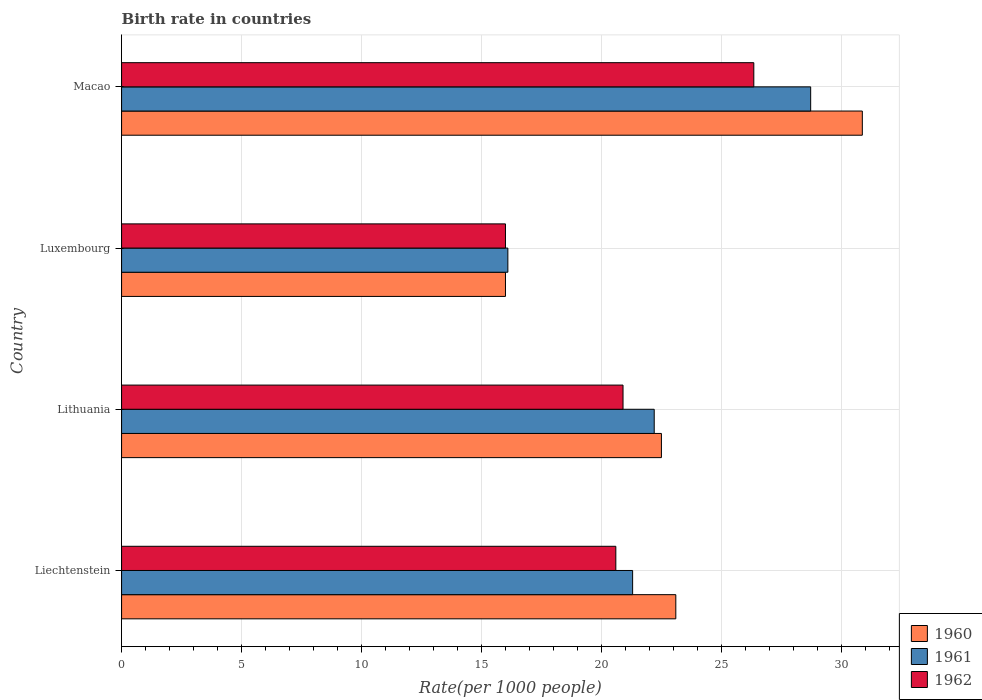Are the number of bars on each tick of the Y-axis equal?
Provide a succinct answer. Yes. How many bars are there on the 3rd tick from the bottom?
Your answer should be very brief. 3. What is the label of the 2nd group of bars from the top?
Make the answer very short. Luxembourg. What is the birth rate in 1960 in Liechtenstein?
Offer a very short reply. 23.1. Across all countries, what is the maximum birth rate in 1962?
Your response must be concise. 26.35. Across all countries, what is the minimum birth rate in 1962?
Ensure brevity in your answer.  16. In which country was the birth rate in 1962 maximum?
Give a very brief answer. Macao. In which country was the birth rate in 1962 minimum?
Keep it short and to the point. Luxembourg. What is the total birth rate in 1961 in the graph?
Your response must be concise. 88.32. What is the difference between the birth rate in 1961 in Liechtenstein and that in Luxembourg?
Provide a succinct answer. 5.2. What is the difference between the birth rate in 1961 in Macao and the birth rate in 1962 in Liechtenstein?
Offer a very short reply. 8.12. What is the average birth rate in 1962 per country?
Offer a very short reply. 20.96. What is the difference between the birth rate in 1961 and birth rate in 1960 in Liechtenstein?
Provide a short and direct response. -1.8. In how many countries, is the birth rate in 1961 greater than 30 ?
Keep it short and to the point. 0. What is the ratio of the birth rate in 1961 in Lithuania to that in Macao?
Make the answer very short. 0.77. Is the birth rate in 1962 in Liechtenstein less than that in Macao?
Give a very brief answer. Yes. Is the difference between the birth rate in 1961 in Liechtenstein and Luxembourg greater than the difference between the birth rate in 1960 in Liechtenstein and Luxembourg?
Your answer should be very brief. No. What is the difference between the highest and the second highest birth rate in 1962?
Your response must be concise. 5.45. What is the difference between the highest and the lowest birth rate in 1961?
Keep it short and to the point. 12.62. Is the sum of the birth rate in 1961 in Luxembourg and Macao greater than the maximum birth rate in 1960 across all countries?
Give a very brief answer. Yes. What does the 2nd bar from the top in Macao represents?
Offer a very short reply. 1961. What does the 1st bar from the bottom in Luxembourg represents?
Your answer should be compact. 1960. Is it the case that in every country, the sum of the birth rate in 1961 and birth rate in 1960 is greater than the birth rate in 1962?
Give a very brief answer. Yes. How many countries are there in the graph?
Your answer should be very brief. 4. Are the values on the major ticks of X-axis written in scientific E-notation?
Offer a terse response. No. How many legend labels are there?
Your response must be concise. 3. How are the legend labels stacked?
Offer a terse response. Vertical. What is the title of the graph?
Offer a very short reply. Birth rate in countries. What is the label or title of the X-axis?
Your answer should be compact. Rate(per 1000 people). What is the label or title of the Y-axis?
Offer a very short reply. Country. What is the Rate(per 1000 people) of 1960 in Liechtenstein?
Make the answer very short. 23.1. What is the Rate(per 1000 people) in 1961 in Liechtenstein?
Ensure brevity in your answer.  21.3. What is the Rate(per 1000 people) in 1962 in Liechtenstein?
Provide a short and direct response. 20.6. What is the Rate(per 1000 people) in 1962 in Lithuania?
Provide a succinct answer. 20.9. What is the Rate(per 1000 people) of 1960 in Luxembourg?
Provide a succinct answer. 16. What is the Rate(per 1000 people) in 1962 in Luxembourg?
Ensure brevity in your answer.  16. What is the Rate(per 1000 people) of 1960 in Macao?
Your answer should be compact. 30.87. What is the Rate(per 1000 people) in 1961 in Macao?
Offer a very short reply. 28.72. What is the Rate(per 1000 people) in 1962 in Macao?
Provide a succinct answer. 26.35. Across all countries, what is the maximum Rate(per 1000 people) in 1960?
Give a very brief answer. 30.87. Across all countries, what is the maximum Rate(per 1000 people) in 1961?
Keep it short and to the point. 28.72. Across all countries, what is the maximum Rate(per 1000 people) of 1962?
Give a very brief answer. 26.35. Across all countries, what is the minimum Rate(per 1000 people) of 1961?
Provide a succinct answer. 16.1. What is the total Rate(per 1000 people) in 1960 in the graph?
Make the answer very short. 92.47. What is the total Rate(per 1000 people) in 1961 in the graph?
Offer a terse response. 88.32. What is the total Rate(per 1000 people) in 1962 in the graph?
Offer a terse response. 83.85. What is the difference between the Rate(per 1000 people) of 1961 in Liechtenstein and that in Lithuania?
Ensure brevity in your answer.  -0.9. What is the difference between the Rate(per 1000 people) in 1961 in Liechtenstein and that in Luxembourg?
Make the answer very short. 5.2. What is the difference between the Rate(per 1000 people) in 1960 in Liechtenstein and that in Macao?
Your response must be concise. -7.77. What is the difference between the Rate(per 1000 people) of 1961 in Liechtenstein and that in Macao?
Ensure brevity in your answer.  -7.42. What is the difference between the Rate(per 1000 people) in 1962 in Liechtenstein and that in Macao?
Provide a succinct answer. -5.75. What is the difference between the Rate(per 1000 people) in 1960 in Lithuania and that in Luxembourg?
Your answer should be very brief. 6.5. What is the difference between the Rate(per 1000 people) of 1960 in Lithuania and that in Macao?
Your answer should be very brief. -8.37. What is the difference between the Rate(per 1000 people) of 1961 in Lithuania and that in Macao?
Keep it short and to the point. -6.52. What is the difference between the Rate(per 1000 people) of 1962 in Lithuania and that in Macao?
Offer a terse response. -5.45. What is the difference between the Rate(per 1000 people) in 1960 in Luxembourg and that in Macao?
Give a very brief answer. -14.87. What is the difference between the Rate(per 1000 people) in 1961 in Luxembourg and that in Macao?
Make the answer very short. -12.62. What is the difference between the Rate(per 1000 people) in 1962 in Luxembourg and that in Macao?
Your answer should be very brief. -10.35. What is the difference between the Rate(per 1000 people) in 1960 in Liechtenstein and the Rate(per 1000 people) in 1961 in Lithuania?
Provide a short and direct response. 0.9. What is the difference between the Rate(per 1000 people) in 1961 in Liechtenstein and the Rate(per 1000 people) in 1962 in Lithuania?
Your answer should be very brief. 0.4. What is the difference between the Rate(per 1000 people) in 1960 in Liechtenstein and the Rate(per 1000 people) in 1961 in Luxembourg?
Provide a short and direct response. 7. What is the difference between the Rate(per 1000 people) of 1960 in Liechtenstein and the Rate(per 1000 people) of 1962 in Luxembourg?
Your response must be concise. 7.1. What is the difference between the Rate(per 1000 people) of 1960 in Liechtenstein and the Rate(per 1000 people) of 1961 in Macao?
Offer a very short reply. -5.62. What is the difference between the Rate(per 1000 people) in 1960 in Liechtenstein and the Rate(per 1000 people) in 1962 in Macao?
Provide a short and direct response. -3.25. What is the difference between the Rate(per 1000 people) in 1961 in Liechtenstein and the Rate(per 1000 people) in 1962 in Macao?
Make the answer very short. -5.05. What is the difference between the Rate(per 1000 people) in 1961 in Lithuania and the Rate(per 1000 people) in 1962 in Luxembourg?
Offer a terse response. 6.2. What is the difference between the Rate(per 1000 people) in 1960 in Lithuania and the Rate(per 1000 people) in 1961 in Macao?
Keep it short and to the point. -6.22. What is the difference between the Rate(per 1000 people) of 1960 in Lithuania and the Rate(per 1000 people) of 1962 in Macao?
Your answer should be compact. -3.85. What is the difference between the Rate(per 1000 people) of 1961 in Lithuania and the Rate(per 1000 people) of 1962 in Macao?
Your answer should be compact. -4.15. What is the difference between the Rate(per 1000 people) in 1960 in Luxembourg and the Rate(per 1000 people) in 1961 in Macao?
Your answer should be very brief. -12.72. What is the difference between the Rate(per 1000 people) of 1960 in Luxembourg and the Rate(per 1000 people) of 1962 in Macao?
Provide a succinct answer. -10.35. What is the difference between the Rate(per 1000 people) of 1961 in Luxembourg and the Rate(per 1000 people) of 1962 in Macao?
Offer a very short reply. -10.25. What is the average Rate(per 1000 people) of 1960 per country?
Your answer should be compact. 23.12. What is the average Rate(per 1000 people) of 1961 per country?
Provide a short and direct response. 22.08. What is the average Rate(per 1000 people) in 1962 per country?
Ensure brevity in your answer.  20.96. What is the difference between the Rate(per 1000 people) of 1960 and Rate(per 1000 people) of 1961 in Lithuania?
Offer a terse response. 0.3. What is the difference between the Rate(per 1000 people) of 1961 and Rate(per 1000 people) of 1962 in Lithuania?
Ensure brevity in your answer.  1.3. What is the difference between the Rate(per 1000 people) of 1960 and Rate(per 1000 people) of 1962 in Luxembourg?
Give a very brief answer. 0. What is the difference between the Rate(per 1000 people) in 1961 and Rate(per 1000 people) in 1962 in Luxembourg?
Offer a terse response. 0.1. What is the difference between the Rate(per 1000 people) in 1960 and Rate(per 1000 people) in 1961 in Macao?
Your answer should be very brief. 2.15. What is the difference between the Rate(per 1000 people) of 1960 and Rate(per 1000 people) of 1962 in Macao?
Offer a terse response. 4.52. What is the difference between the Rate(per 1000 people) of 1961 and Rate(per 1000 people) of 1962 in Macao?
Keep it short and to the point. 2.37. What is the ratio of the Rate(per 1000 people) of 1960 in Liechtenstein to that in Lithuania?
Provide a short and direct response. 1.03. What is the ratio of the Rate(per 1000 people) of 1961 in Liechtenstein to that in Lithuania?
Ensure brevity in your answer.  0.96. What is the ratio of the Rate(per 1000 people) of 1962 in Liechtenstein to that in Lithuania?
Keep it short and to the point. 0.99. What is the ratio of the Rate(per 1000 people) in 1960 in Liechtenstein to that in Luxembourg?
Give a very brief answer. 1.44. What is the ratio of the Rate(per 1000 people) of 1961 in Liechtenstein to that in Luxembourg?
Your answer should be very brief. 1.32. What is the ratio of the Rate(per 1000 people) in 1962 in Liechtenstein to that in Luxembourg?
Keep it short and to the point. 1.29. What is the ratio of the Rate(per 1000 people) of 1960 in Liechtenstein to that in Macao?
Give a very brief answer. 0.75. What is the ratio of the Rate(per 1000 people) of 1961 in Liechtenstein to that in Macao?
Provide a short and direct response. 0.74. What is the ratio of the Rate(per 1000 people) in 1962 in Liechtenstein to that in Macao?
Provide a short and direct response. 0.78. What is the ratio of the Rate(per 1000 people) of 1960 in Lithuania to that in Luxembourg?
Your answer should be compact. 1.41. What is the ratio of the Rate(per 1000 people) in 1961 in Lithuania to that in Luxembourg?
Keep it short and to the point. 1.38. What is the ratio of the Rate(per 1000 people) in 1962 in Lithuania to that in Luxembourg?
Your response must be concise. 1.31. What is the ratio of the Rate(per 1000 people) in 1960 in Lithuania to that in Macao?
Ensure brevity in your answer.  0.73. What is the ratio of the Rate(per 1000 people) in 1961 in Lithuania to that in Macao?
Offer a very short reply. 0.77. What is the ratio of the Rate(per 1000 people) in 1962 in Lithuania to that in Macao?
Your answer should be very brief. 0.79. What is the ratio of the Rate(per 1000 people) in 1960 in Luxembourg to that in Macao?
Give a very brief answer. 0.52. What is the ratio of the Rate(per 1000 people) in 1961 in Luxembourg to that in Macao?
Provide a short and direct response. 0.56. What is the ratio of the Rate(per 1000 people) in 1962 in Luxembourg to that in Macao?
Make the answer very short. 0.61. What is the difference between the highest and the second highest Rate(per 1000 people) of 1960?
Provide a short and direct response. 7.77. What is the difference between the highest and the second highest Rate(per 1000 people) of 1961?
Ensure brevity in your answer.  6.52. What is the difference between the highest and the second highest Rate(per 1000 people) of 1962?
Your answer should be compact. 5.45. What is the difference between the highest and the lowest Rate(per 1000 people) of 1960?
Provide a short and direct response. 14.87. What is the difference between the highest and the lowest Rate(per 1000 people) of 1961?
Keep it short and to the point. 12.62. What is the difference between the highest and the lowest Rate(per 1000 people) in 1962?
Your response must be concise. 10.35. 